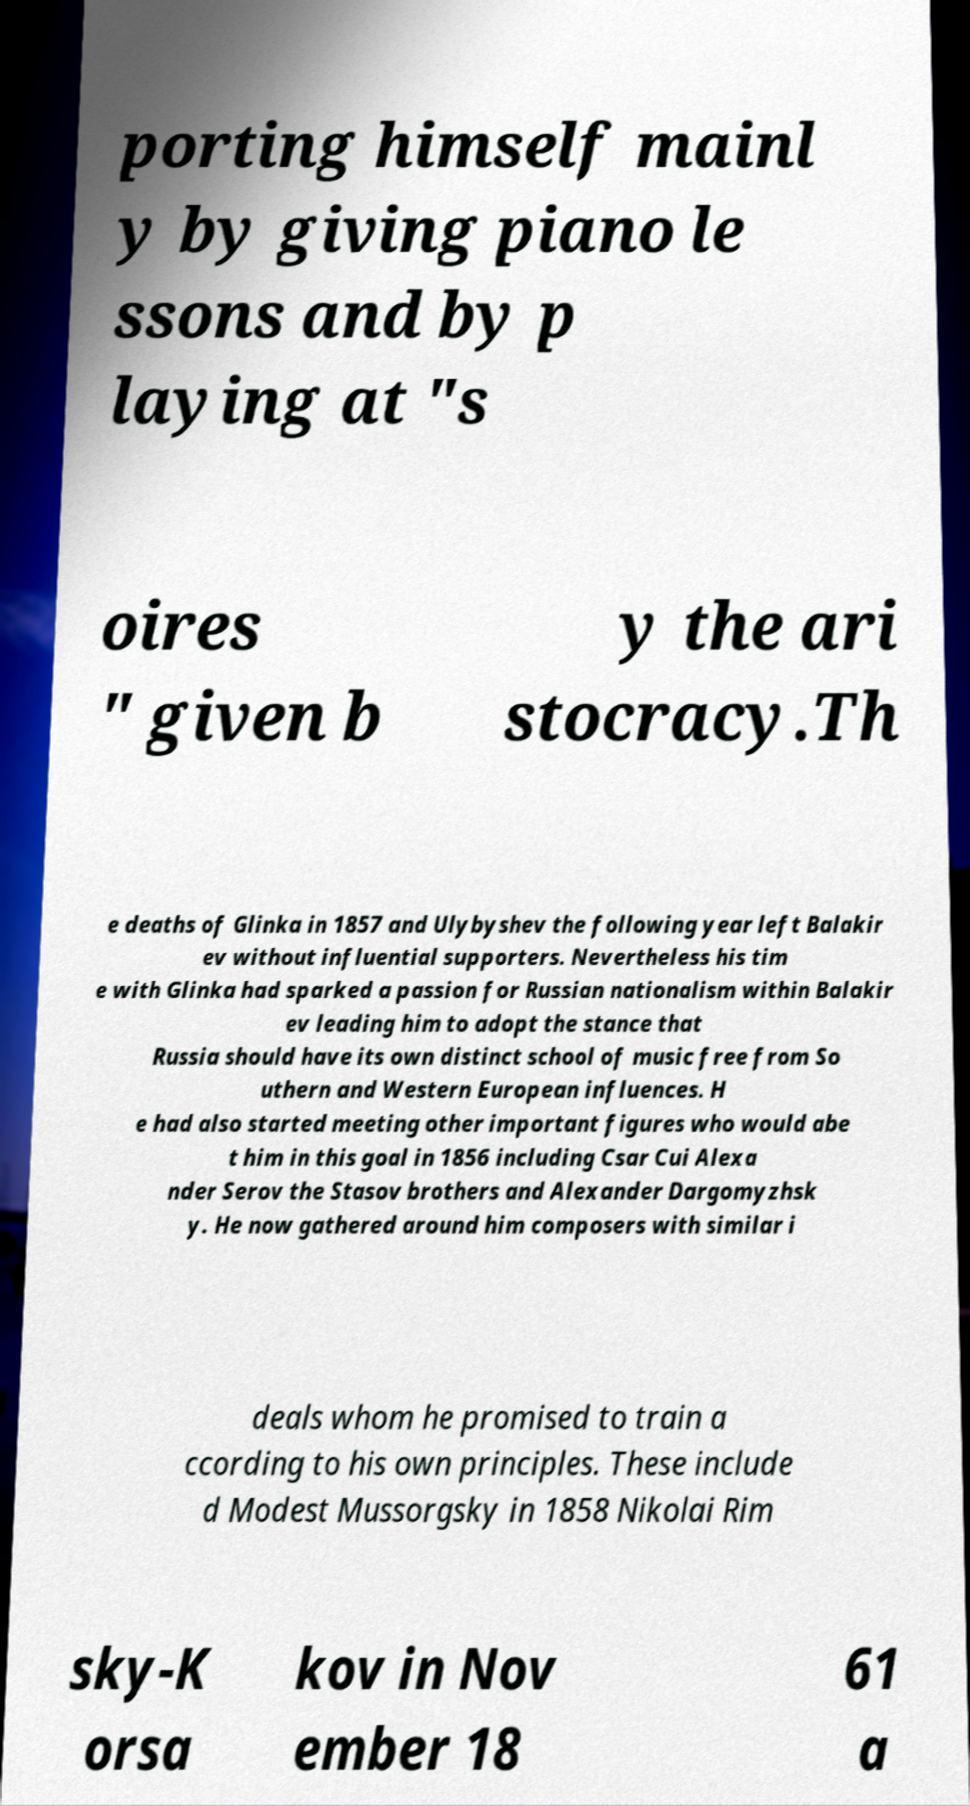What messages or text are displayed in this image? I need them in a readable, typed format. porting himself mainl y by giving piano le ssons and by p laying at "s oires " given b y the ari stocracy.Th e deaths of Glinka in 1857 and Ulybyshev the following year left Balakir ev without influential supporters. Nevertheless his tim e with Glinka had sparked a passion for Russian nationalism within Balakir ev leading him to adopt the stance that Russia should have its own distinct school of music free from So uthern and Western European influences. H e had also started meeting other important figures who would abe t him in this goal in 1856 including Csar Cui Alexa nder Serov the Stasov brothers and Alexander Dargomyzhsk y. He now gathered around him composers with similar i deals whom he promised to train a ccording to his own principles. These include d Modest Mussorgsky in 1858 Nikolai Rim sky-K orsa kov in Nov ember 18 61 a 